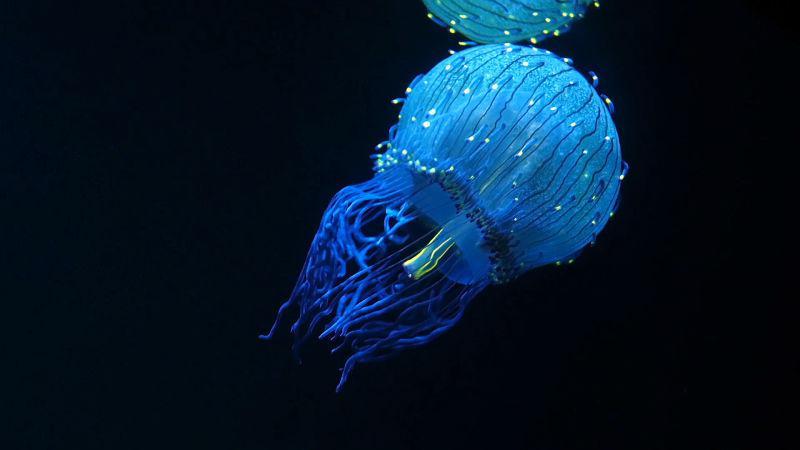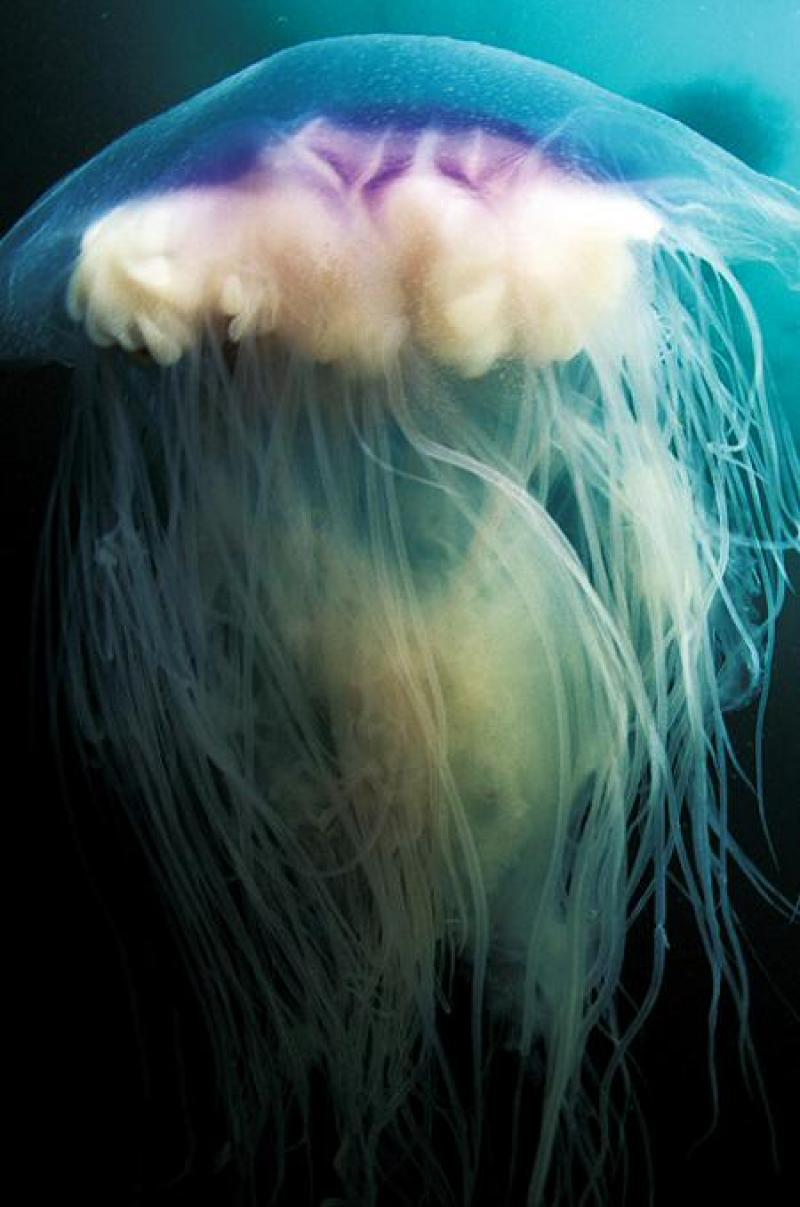The first image is the image on the left, the second image is the image on the right. For the images displayed, is the sentence "All the organisms have long tentacles." factually correct? Answer yes or no. Yes. 